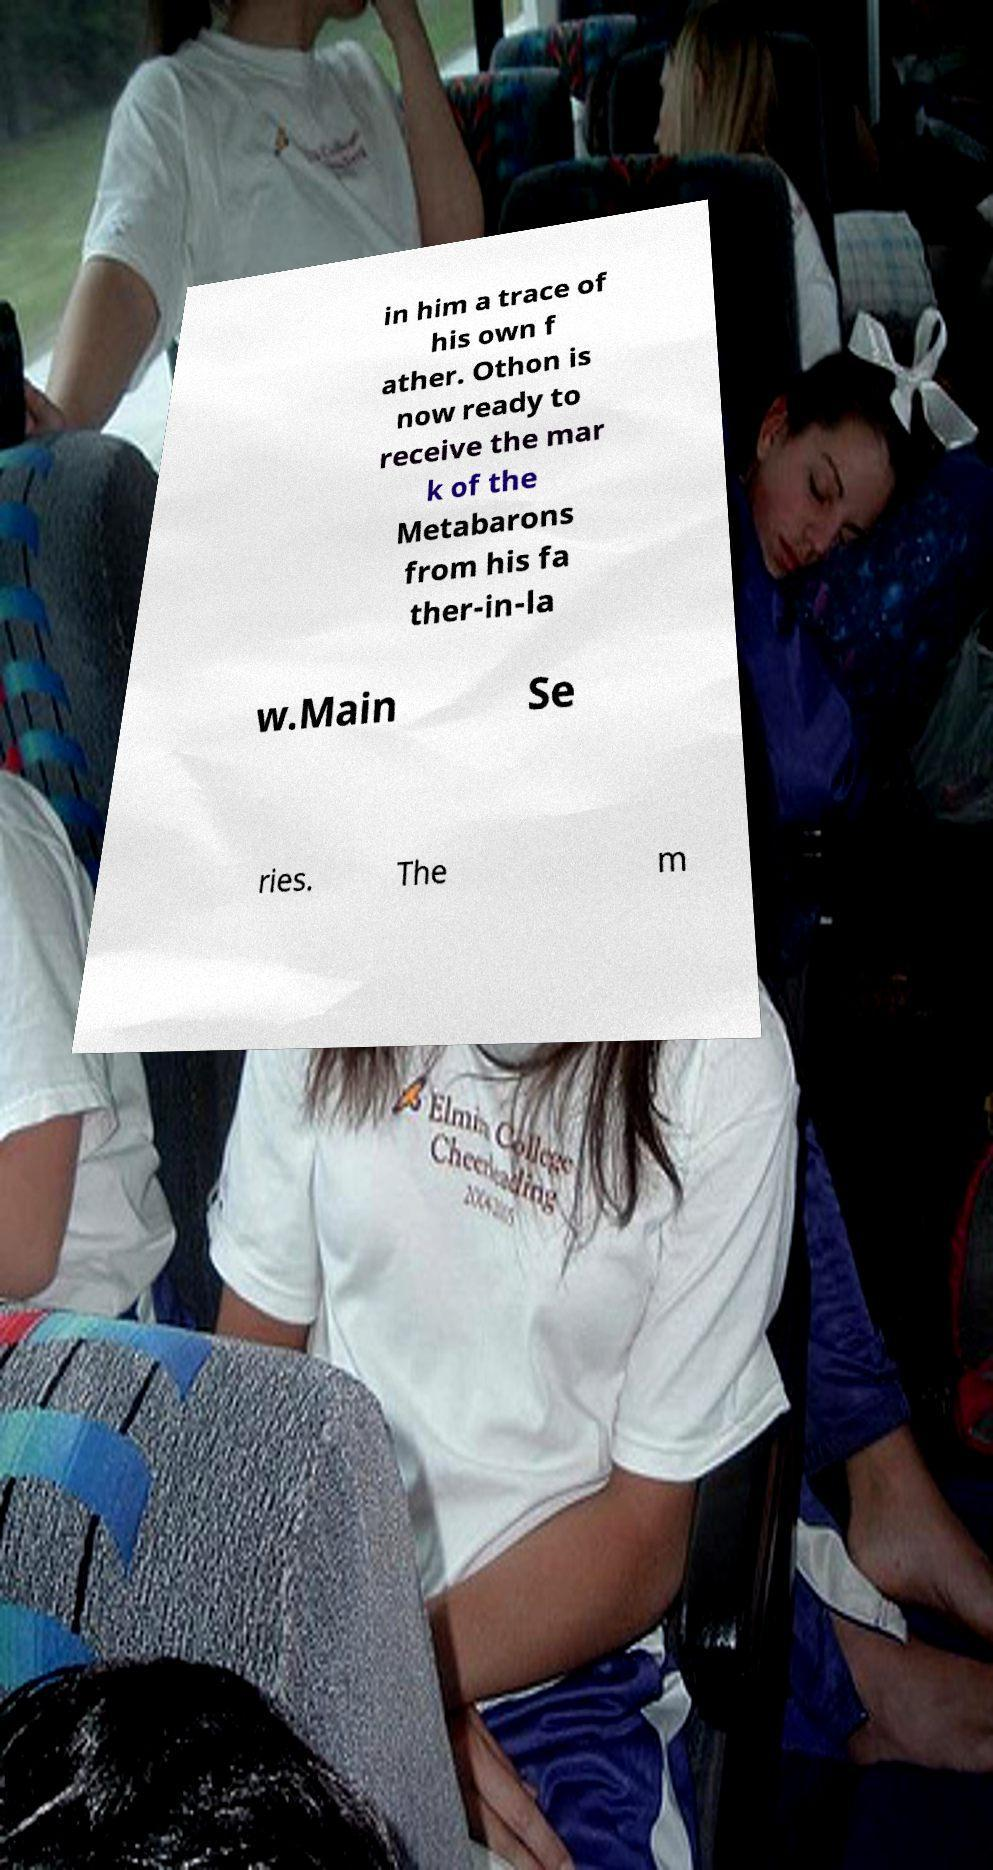Can you accurately transcribe the text from the provided image for me? in him a trace of his own f ather. Othon is now ready to receive the mar k of the Metabarons from his fa ther-in-la w.Main Se ries. The m 